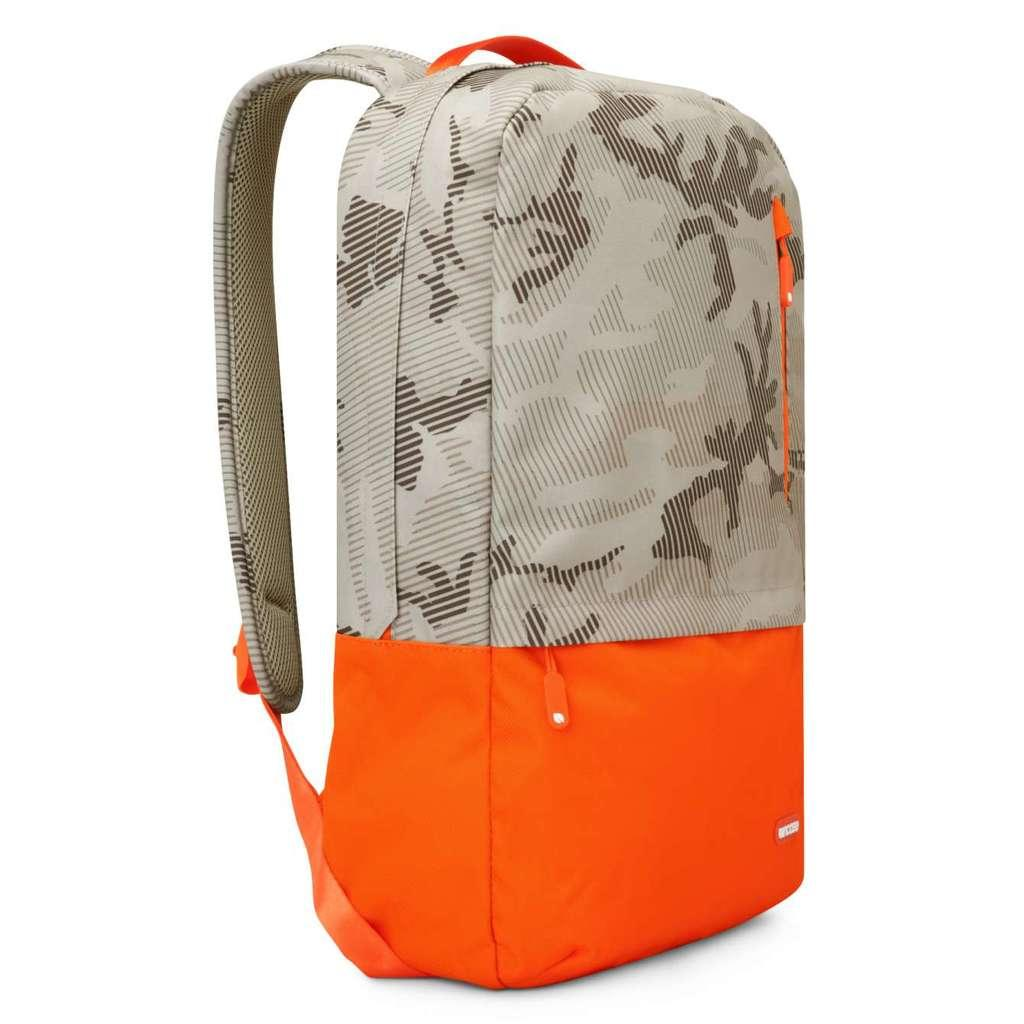What object can be seen in the image? There is a bag in the image. Can you describe the color of the bag? The bag is brown and orange in color. Reasoning: Let's think step by identifying the main subject in the image, which is the bag. Then, we focus on a specific detail about the bag, which is its color. Each question is designed to elicit a specific detail about the image that is known from the provided facts. Absurd Question/Answer: What country is the bag connected to in the image? There is no country or connection mentioned in the image; it only shows a brown and orange bag. What is the end result of the bag in the image? There is no end result or action associated with the bag in the image; it is simply a brown and orange bag. 